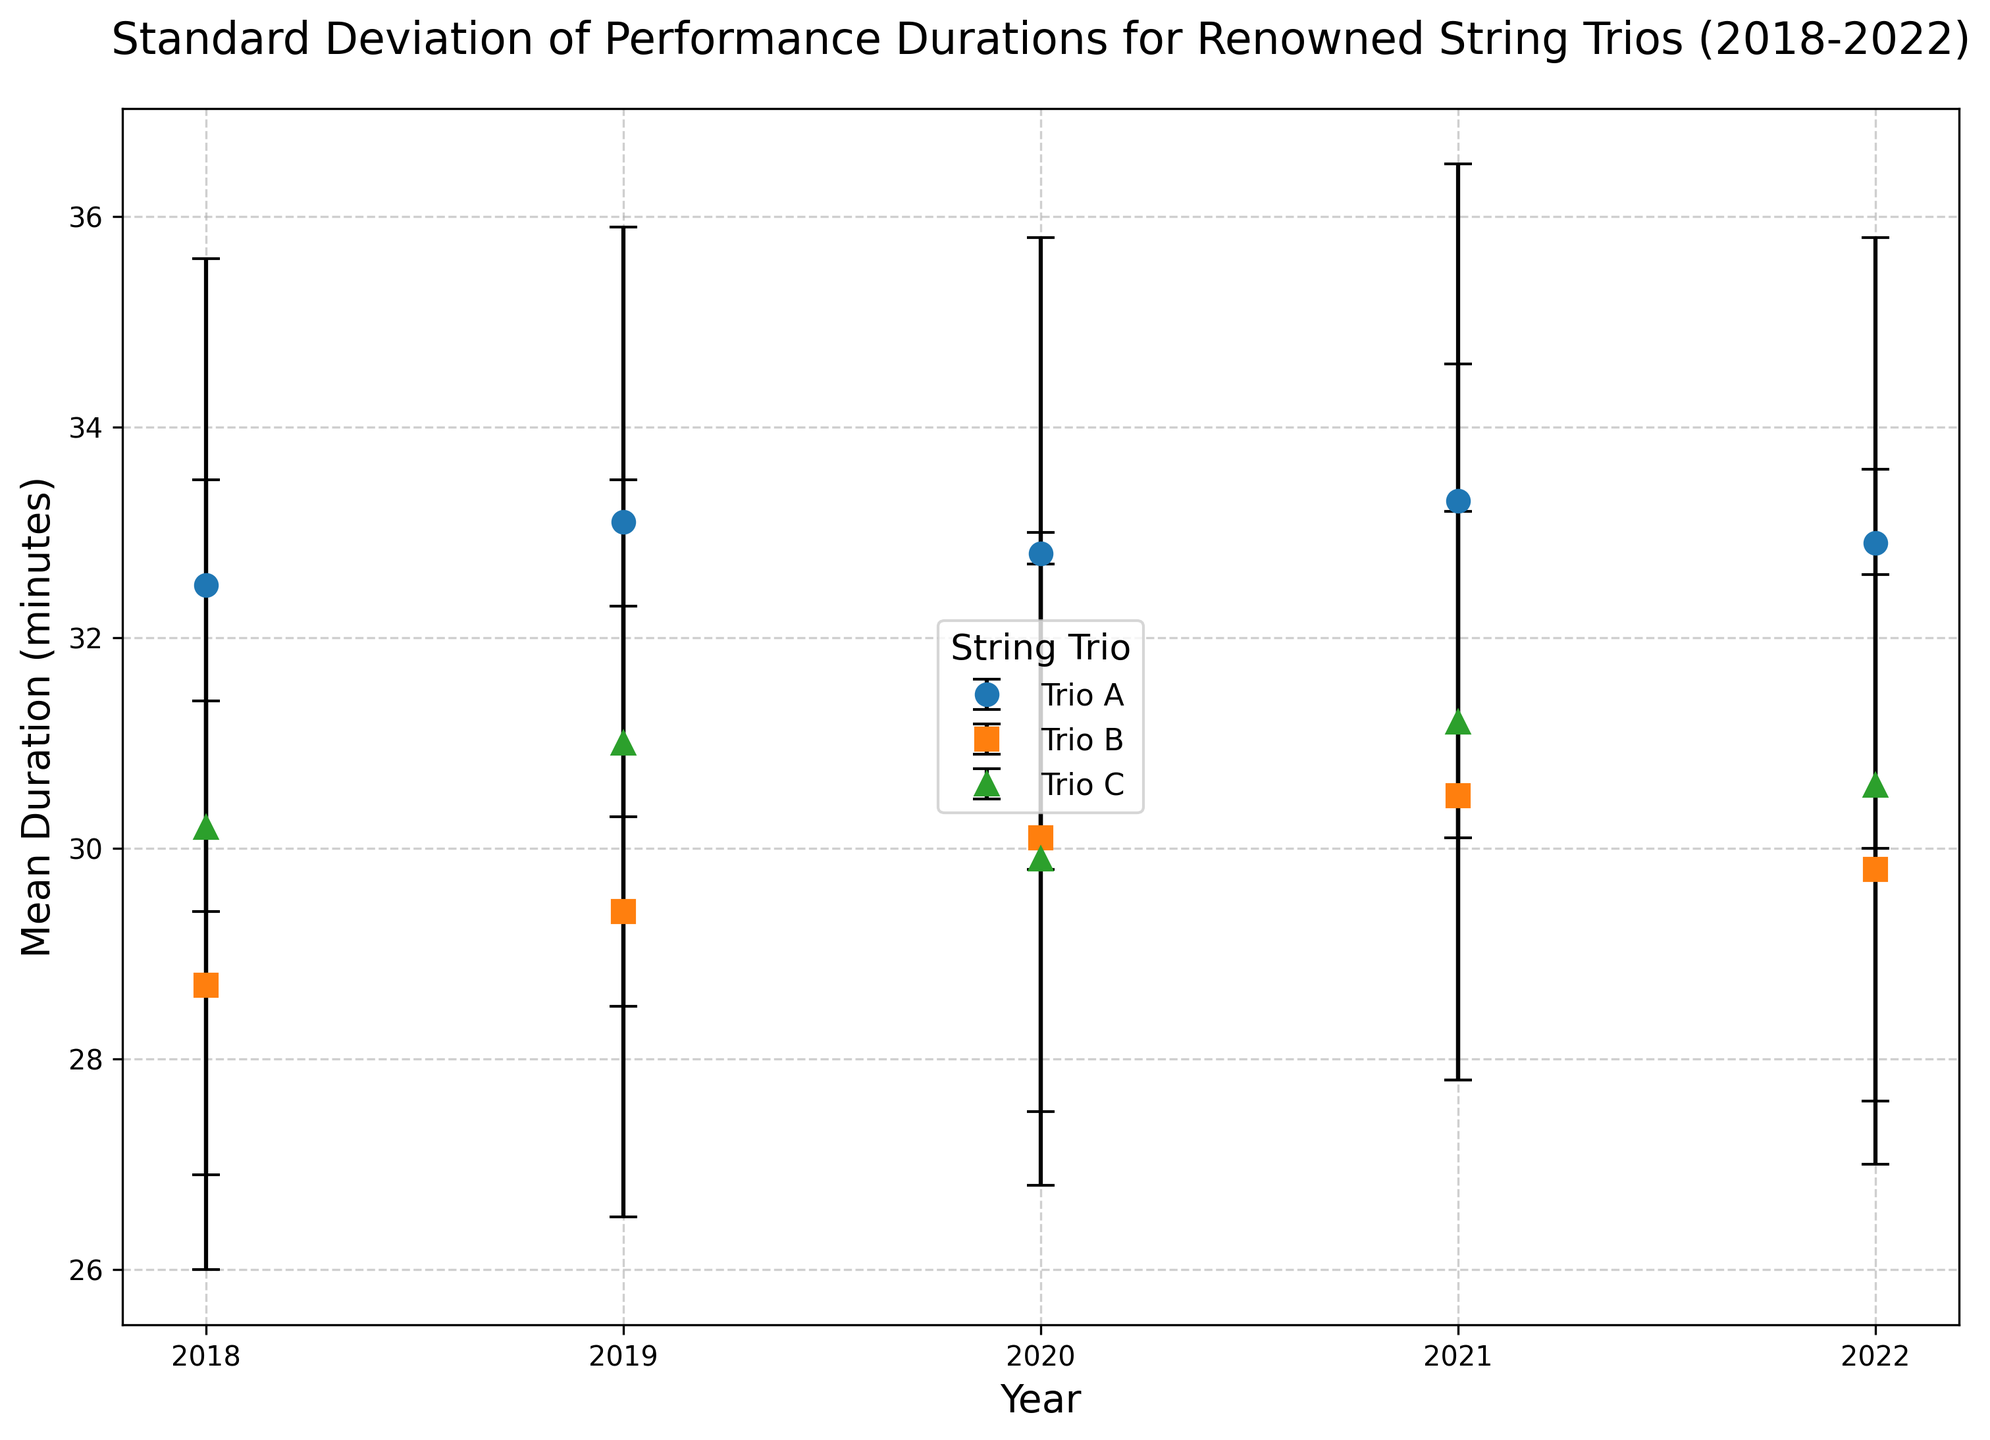Which trio had the highest mean duration in 2021? To identify which trio had the highest mean duration in 2021, look at the data points for each trio in that particular year. Trio A has 33.3 minutes, Trio B has 30.5 minutes, and Trio C has 31.2 minutes. Therefore, Trio A had the highest mean duration.
Answer: Trio A Which year had the lowest mean duration for Trio B? Compare the mean durations of Trio B across the years 2018 to 2022. In 2018, the mean duration was 28.7 minutes, which is the lowest compared to 29.4 minutes (2019), 30.1 minutes (2020), 30.5 minutes (2021), and 29.8 minutes (2022).
Answer: 2018 What is the average mean duration over five years for Trio C? To compute the average mean duration of Trio C over five years, sum the mean durations from each year and divide by the number of years. (30.2 + 31.0 + 29.9 + 31.2 + 30.6) / 5 = 152.9 / 5.
Answer: 30.58 minutes Which trio had the most consistent performance durations in 2020 based on the standard deviation? The most consistent performance durations would be indicated by the lowest standard deviation. In 2020, Trio A had a std deviation of 3.0 minutes, Trio B had 2.6 minutes, and Trio C had 3.1 minutes. Therefore, Trio B was the most consistent.
Answer: Trio B Which trio shows an increase in mean duration every year? Reviewing the mean durations for each trio across the years will show the trend. Trio A's durations are 32.5 (2018), 33.1 (2019), 32.8 (2020), 33.3 (2021), 32.9 (2022). Trio B's durations are 28.7 (2018), 29.4 (2019), 30.1 (2020), 30.5 (2021), 29.8 (2022). Trio C's are 30.2 (2018), 31.0 (2019), 29.9 (2020), 31.2 (2021), 30.6 (2022). No trio shows a consistent increase every year.
Answer: None 